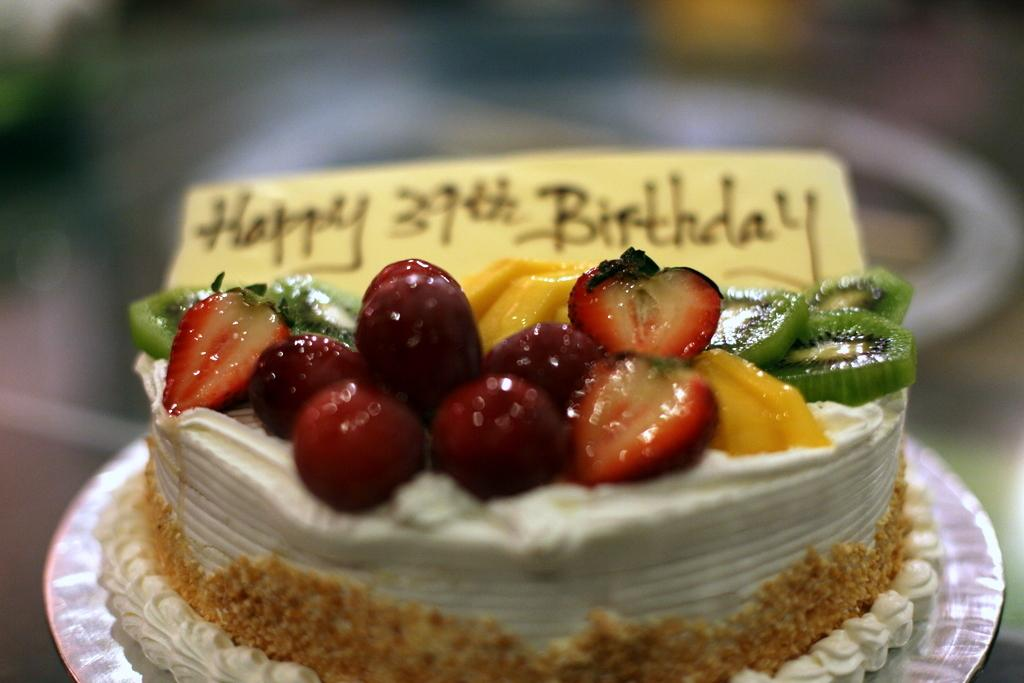What is the main food item featured on a plate in the image? There is a cake on a plate in the image. What other items can be seen in the image besides the cake? There are fruits in the image. Can you describe any additional details about the cake? There is text on the cake. How would you describe the overall appearance of the image? The background of the image is blurry. What type of boot is being worn by the family while reading in the image? There is no boot, family, or reading activity present in the image. 